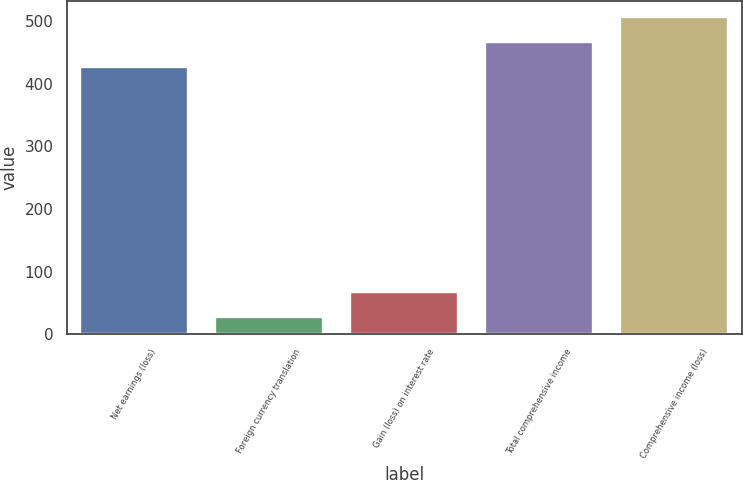Convert chart to OTSL. <chart><loc_0><loc_0><loc_500><loc_500><bar_chart><fcel>Net earnings (loss)<fcel>Foreign currency translation<fcel>Gain (loss) on interest rate<fcel>Total comprehensive income<fcel>Comprehensive income (loss)<nl><fcel>427<fcel>27<fcel>67<fcel>467<fcel>507<nl></chart> 